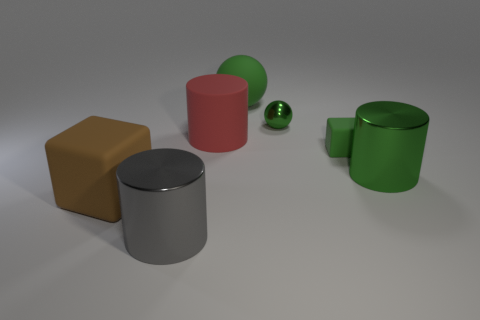Add 1 gray objects. How many objects exist? 8 Subtract all spheres. How many objects are left? 5 Subtract all red balls. Subtract all brown cubes. How many objects are left? 6 Add 7 shiny cylinders. How many shiny cylinders are left? 9 Add 2 metallic spheres. How many metallic spheres exist? 3 Subtract 0 cyan balls. How many objects are left? 7 